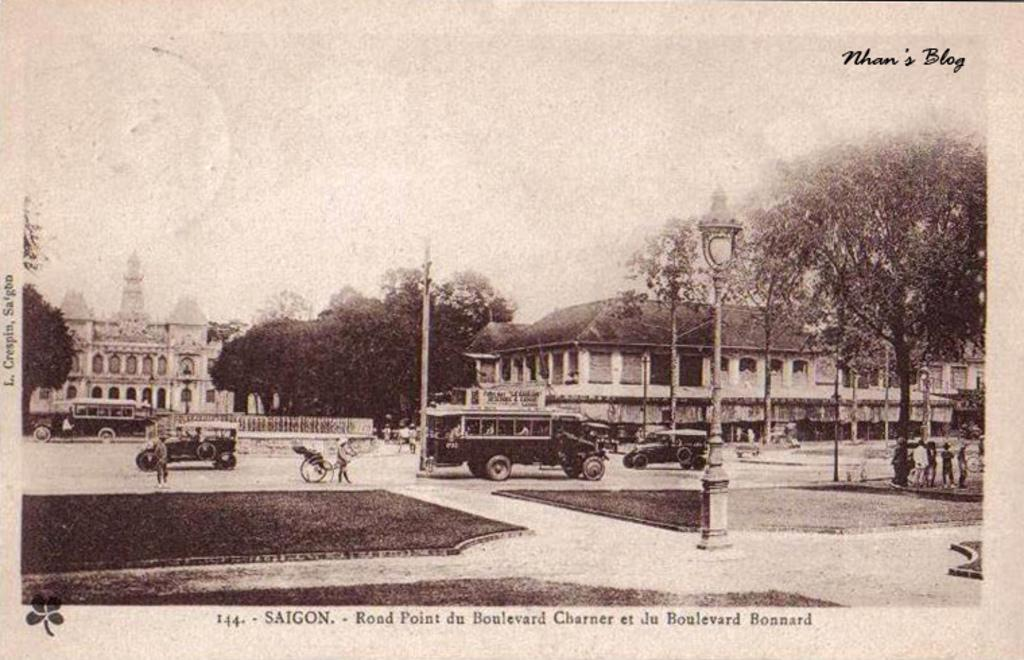<image>
Share a concise interpretation of the image provided. An old image of Saigon is numbered 144 and shows a street scene. 